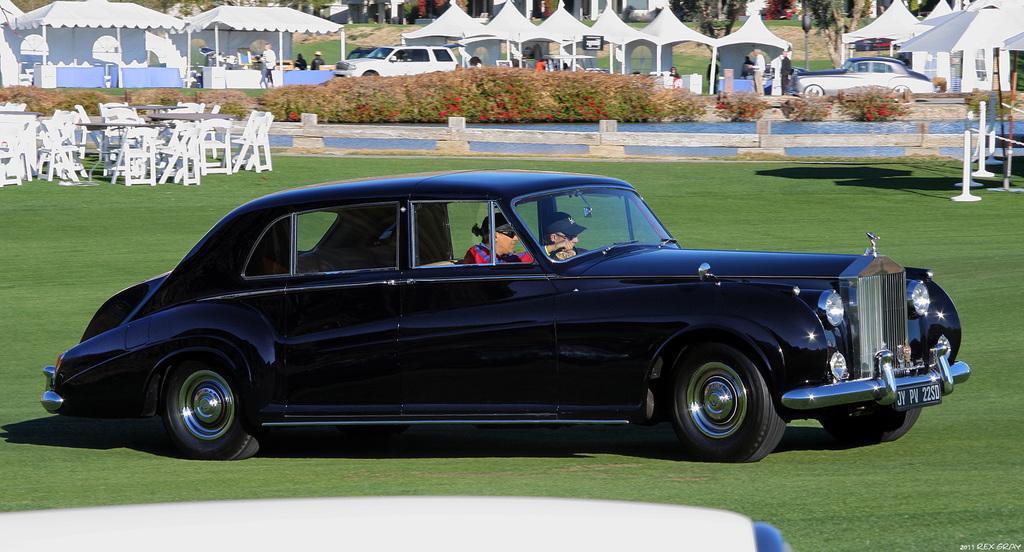Please provide a concise description of this image. In this image we can see a car. Inside the car there are two persons. On the ground there is grass. On the left side there are chairs and tables. In the back there are plants. Also there are tents and few people. And there are vehicles. 